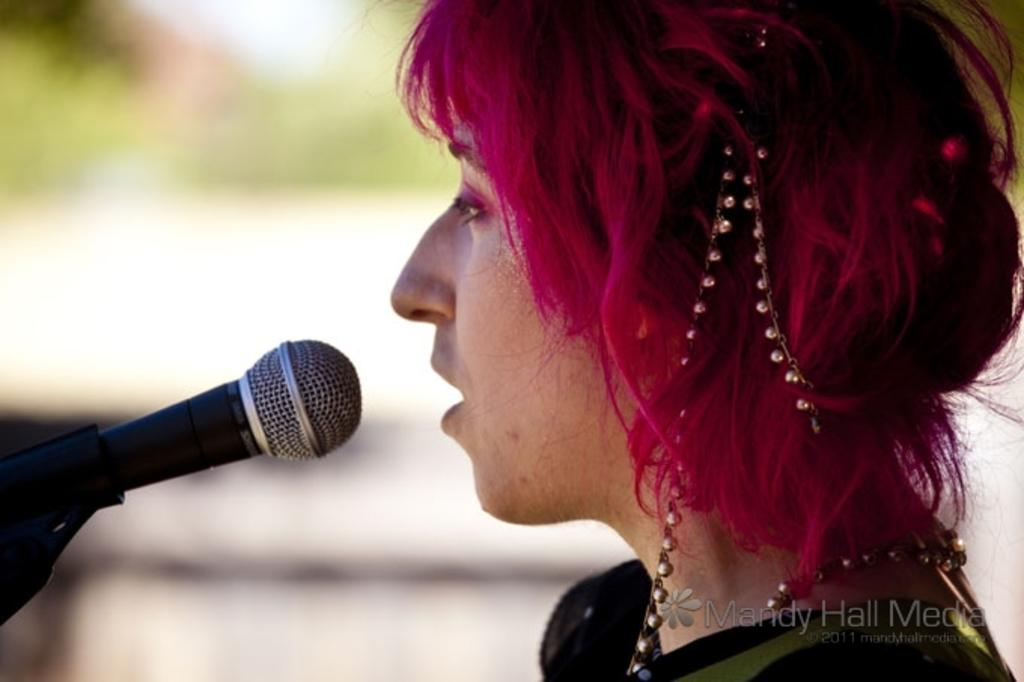Who is the main subject in the image? There is a woman in the image. What object is present in the image that is typically used for amplifying sound? There is a microphone on a stand in the image. What type of accessory is the woman wearing in her hair? The woman has a beads chain on her hair. What type of accessory is the woman wearing around her neck? The woman has a beads chain around her neck. How would you describe the background of the image? The background of the image is blurred. Can you see a dog in the image? No, there is no dog present in the image. Is the woman breathing heavily in the image? There is no indication of the woman's breathing in the image, as it only shows her standing with a microphone and beads chains. 